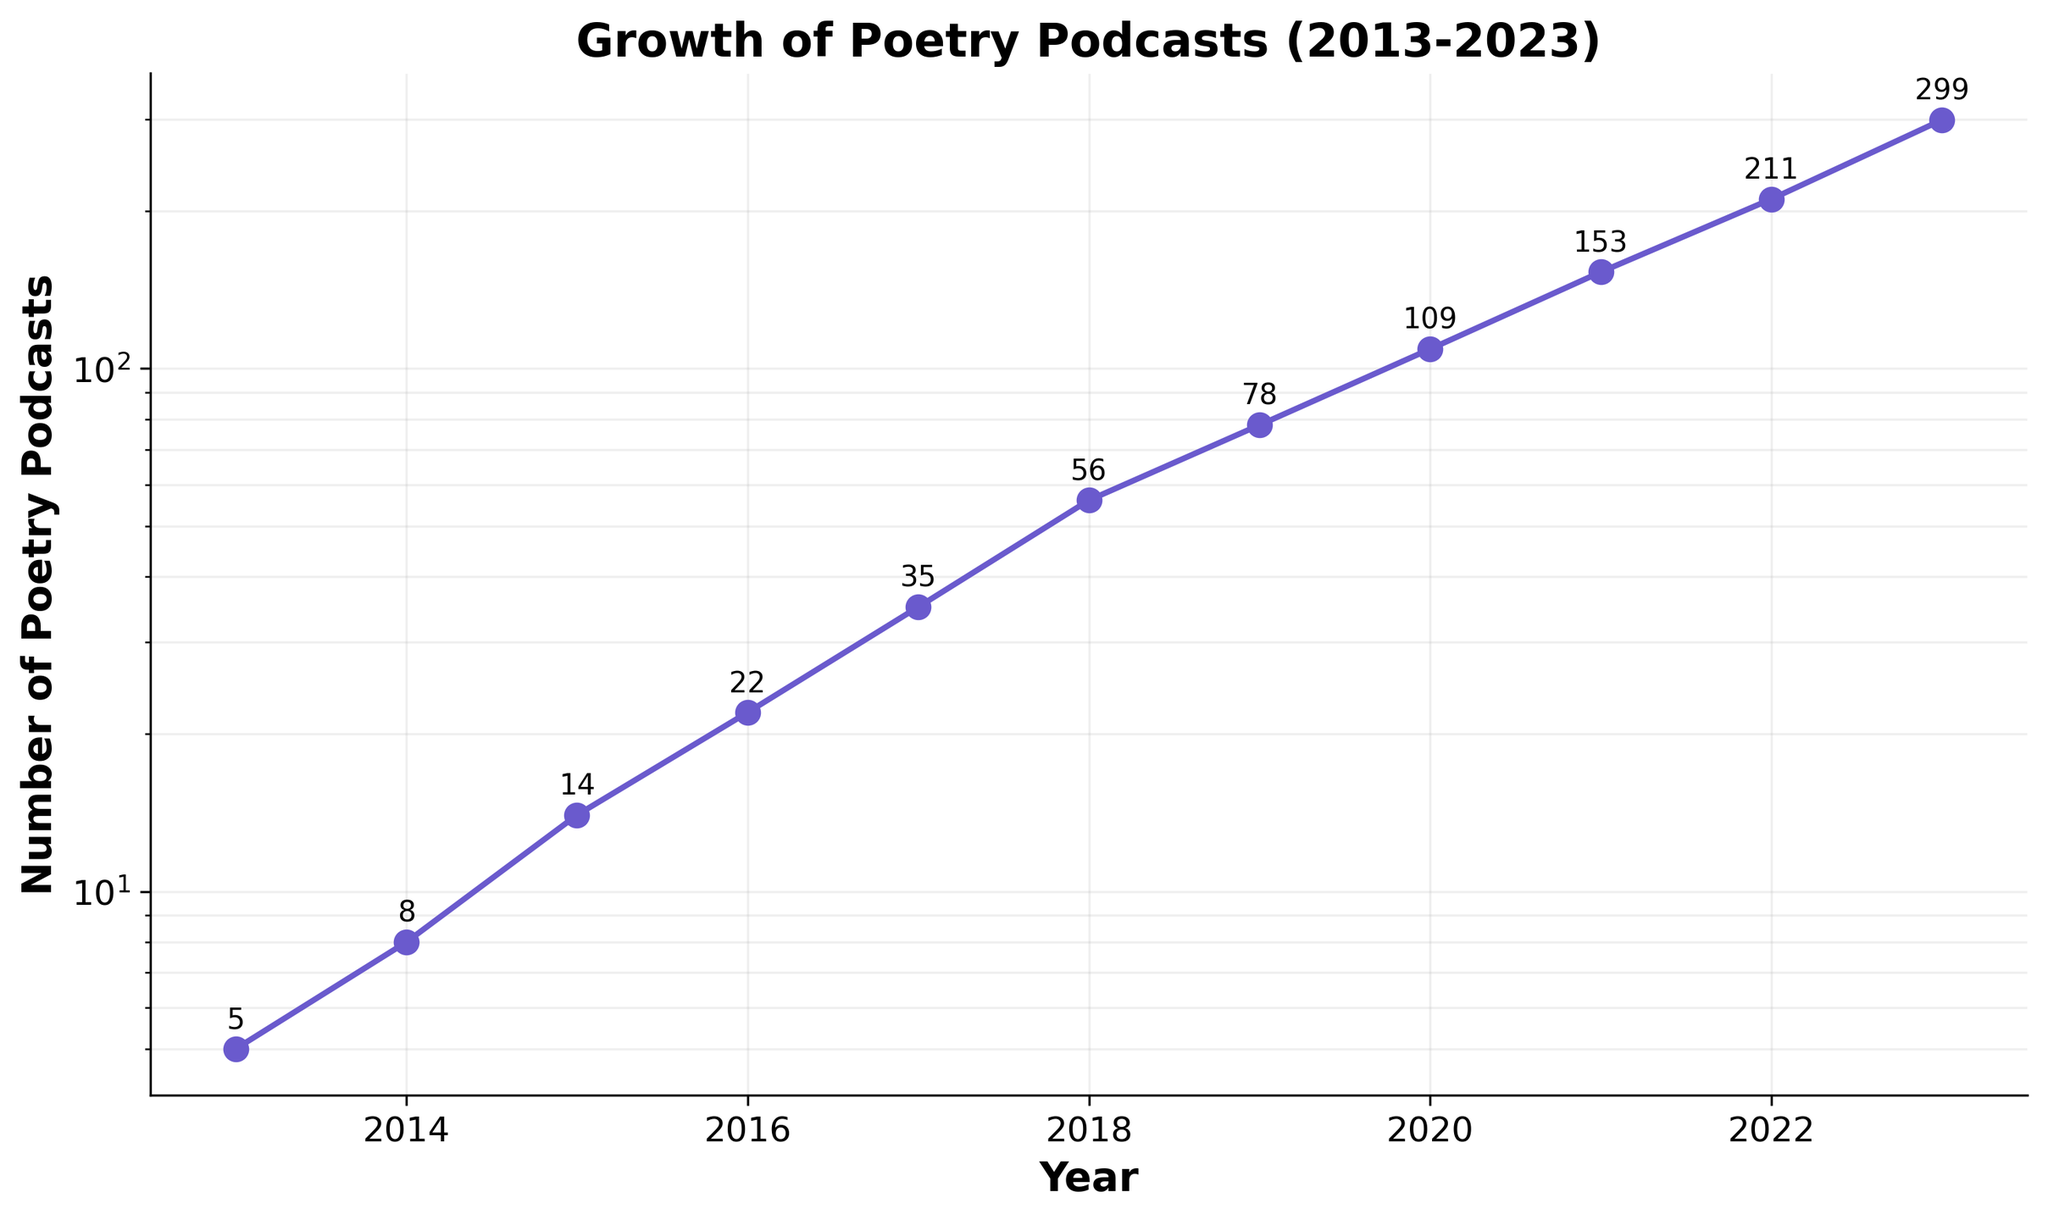How many years are represented in the plot? Count the number of distinct years along the x-axis. From 2013 to 2023, there are 11 years total.
Answer: 11 What is the title of the figure? The title of the figure is clearly displayed at the top of the plot.
Answer: Growth of Poetry Podcasts (2013-2023) What was the number of poetry podcasts in 2016? Locate the year 2016 on the x-axis, then look at the corresponding point on the y-axis. The annotation reads 22.
Answer: 22 How has the number of poetry podcasts changed from 2013 to 2023? The number in 2013 was 5, and it increased to 299 in 2023. The difference is 299 - 5 = 294.
Answer: Increased by 294 During which year did the number of poetry podcasts first exceed 100? Find where the y-axis value first exceeds 100. The first year with a value greater than 100 is 2020, with 109 podcasts.
Answer: 2020 What is the average growth rate per year of the number of poetry podcasts? Compute the increase from 2013 to 2023 (299 - 5 = 294). Divide this by the number of years (2023 - 2013 = 10). The average growth rate is 294 / 10 = 29.4 podcasts per year.
Answer: 29.4 podcasts per year Which year had the largest numerical increase in the number of poetry podcasts compared to the previous year? Calculate the differences between consecutive years: 2014 (3), 2015 (6), 2016 (8), 2017 (13), 2018 (21), 2019 (22), 2020 (31), 2021 (44), 2022 (58), 2023 (88). The largest increase happened between 2022 and 2023, with 88 new podcasts.
Answer: 2023 How does the plot utilize the semi-logarithmic scale? The y-axis is logarithmic, meaning each increment represents a tenfold increase, which helps to visualize exponential growth more clearly.
Answer: Logarithmic y-axis What is the median number of poetry podcasts over the years represented? List the values: 5, 8, 14, 22, 35, 56, 78, 109, 153, 211, 299. The middle value (median) in this ordered list is the 6th value, which is 56.
Answer: 56 Which year had the smallest increase in the number of poetry podcasts compared to the previous year? Calculate the smallest increases between consecutive years: 2014 (3), 2015 (6), 2016 (8), 2017 (13), 2018 (21), 2019 (22), 2020 (31), 2021 (44), 2022 (58), 2023 (88). The smallest increase occurred between 2013 and 2014 with an increase of 3.
Answer: 2014 